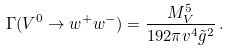<formula> <loc_0><loc_0><loc_500><loc_500>\Gamma ( V ^ { 0 } \to w ^ { + } w ^ { - } ) = { \frac { M _ { V } ^ { 5 } } { 1 9 2 \pi v ^ { 4 } \tilde { g } ^ { 2 } } } \, .</formula> 